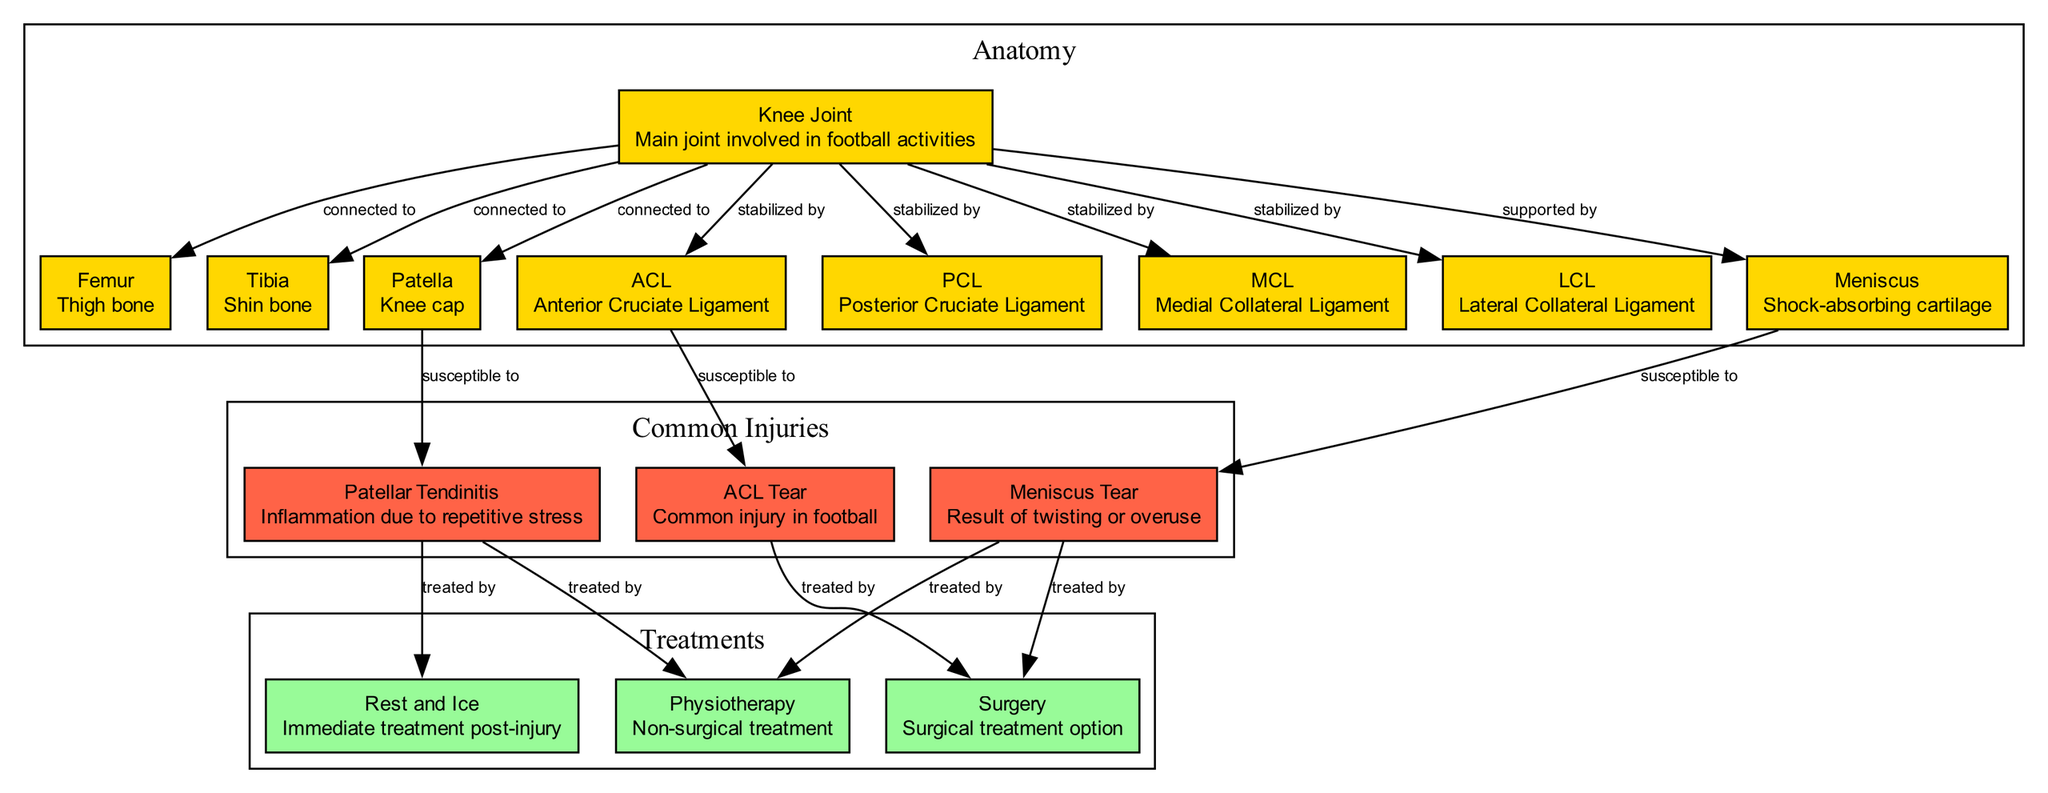What is the main joint involved in football activities? The diagram indicates that the "Knee Joint" is the main joint involved in football activities. This can be inferred directly from the label of the node that represents the knee joint.
Answer: Knee Joint How many ligaments stabilize the knee joint? By examining the nodes connected to the "Knee Joint" that denote stability, we see four ligaments: ACL, PCL, MCL, and LCL, hence there are four ligaments stabilizing the knee joint.
Answer: Four Which injury is the ACL susceptible to? The diagram illustrates that the "ACL Tear" is the injury that is specifically linked to the "ACL," making it clear that the ACL is susceptible to this injury.
Answer: ACL Tear What treatment method is used for a meniscus tear? The diagram shows two treatments linked to "Meniscus Tear": "Surgery" and "Physiotherapy." Hence, either of these treatment methods can be used for a meniscus tear.
Answer: Surgery or Physiotherapy What is the relationship between the patella and patellar tendinitis? The diagram shows that the "Patella" is susceptible to "Patellar Tendinitis," indicating a direct relationship where the patella can lead to this condition due to repetitive stress.
Answer: Susceptible to Name two treatments for patellar tendinitis. The diagram indicates three treatment options for "Patellar Tendinitis": "Physiotherapy," "Surgery," and "Rest and Ice." Thus, two possible treatments can be "Physiotherapy" and "Rest and Ice."
Answer: Physiotherapy, Rest and Ice Which bone supports the knee joint alongside the femur? The diagram clearly shows that the "Tibia" is also connected to the "Knee Joint," indicating that it supports the knee joint along with the femur.
Answer: Tibia How does a meniscus tear occur? The diagram specifies that a meniscus tear can result from "Twisting" or "Overuse," indicating these are the common mechanisms that lead to this injury.
Answer: Twisting or Overuse What immediate treatment should be applied post-injury? According to the diagram, "Rest and Ice" is indicated as the immediate treatment following an injury, providing a clear guideline for initial care.
Answer: Rest and Ice 